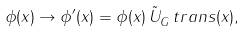Convert formula to latex. <formula><loc_0><loc_0><loc_500><loc_500>\phi ( x ) \rightarrow \phi ^ { \prime } ( x ) = \phi ( x ) \, \tilde { U } _ { G } ^ { \ } t r a n s ( x ) ,</formula> 